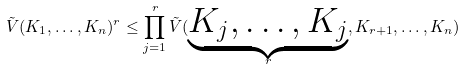Convert formula to latex. <formula><loc_0><loc_0><loc_500><loc_500>\tilde { V } ( K _ { 1 } , \dots , K _ { n } ) ^ { r } \leq \prod _ { j = 1 } ^ { r } \tilde { V } ( \underbrace { K _ { j } , \dots , K _ { j } } _ { r } , K _ { r + 1 } , \dots , K _ { n } )</formula> 